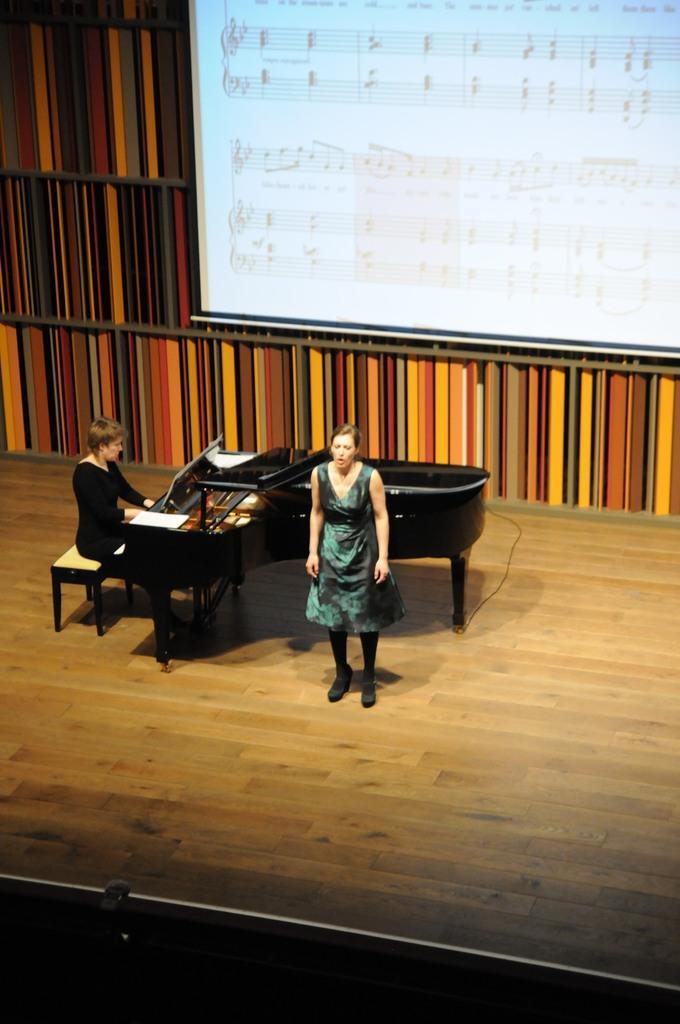Please provide a concise description of this image. In this image i can see a woman standing and a woman sitting, the woman on the left side is sitting on a bench in front of a piano. In the background i can see a wall and a screen. 